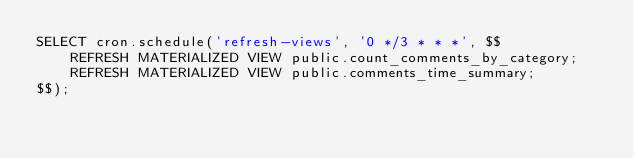Convert code to text. <code><loc_0><loc_0><loc_500><loc_500><_SQL_>SELECT cron.schedule('refresh-views', '0 */3 * * *', $$
    REFRESH MATERIALIZED VIEW public.count_comments_by_category;
    REFRESH MATERIALIZED VIEW public.comments_time_summary;
$$);
</code> 